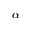<formula> <loc_0><loc_0><loc_500><loc_500>\boldsymbol \alpha</formula> 